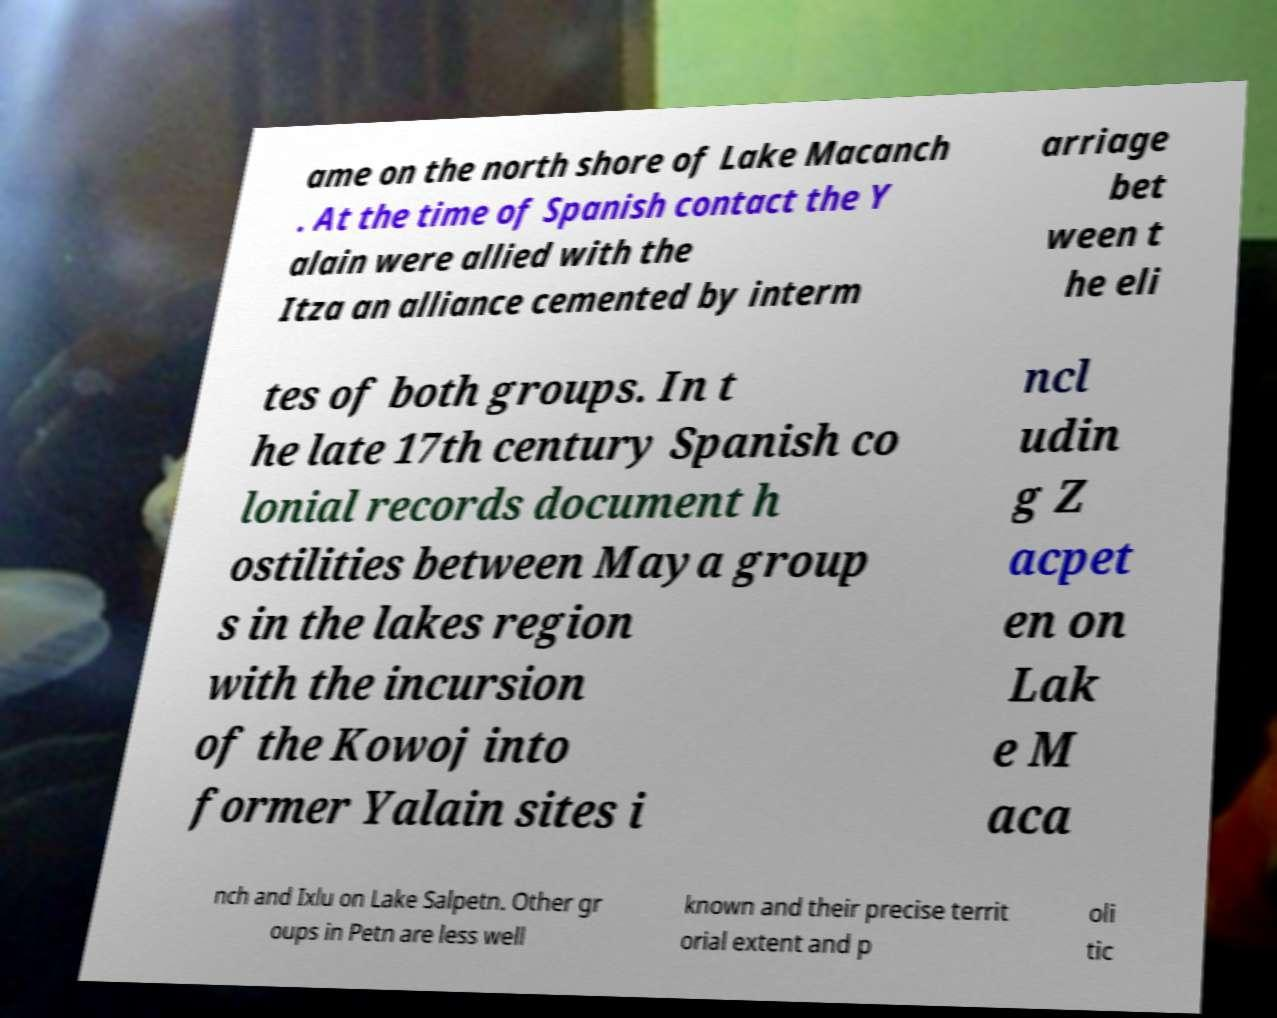There's text embedded in this image that I need extracted. Can you transcribe it verbatim? ame on the north shore of Lake Macanch . At the time of Spanish contact the Y alain were allied with the Itza an alliance cemented by interm arriage bet ween t he eli tes of both groups. In t he late 17th century Spanish co lonial records document h ostilities between Maya group s in the lakes region with the incursion of the Kowoj into former Yalain sites i ncl udin g Z acpet en on Lak e M aca nch and Ixlu on Lake Salpetn. Other gr oups in Petn are less well known and their precise territ orial extent and p oli tic 